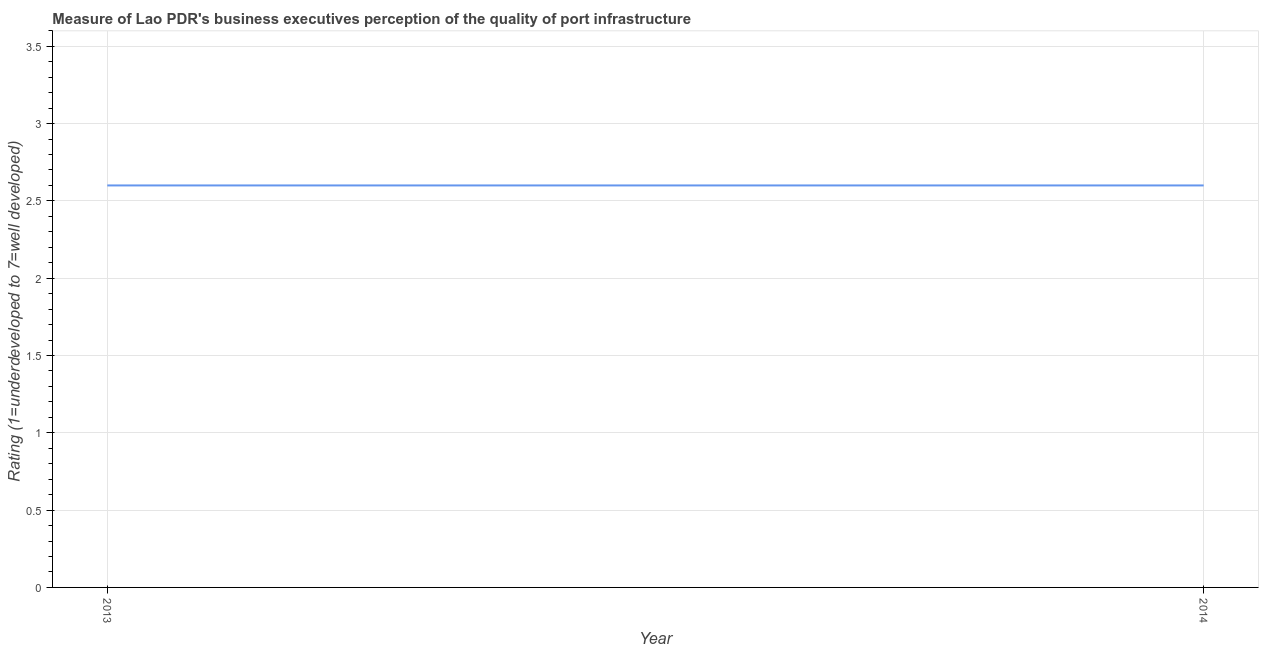What is the rating measuring quality of port infrastructure in 2014?
Offer a very short reply. 2.6. What is the difference between the rating measuring quality of port infrastructure in 2013 and 2014?
Your answer should be very brief. 0. What is the median rating measuring quality of port infrastructure?
Your response must be concise. 2.6. In how many years, is the rating measuring quality of port infrastructure greater than 2.4 ?
Provide a succinct answer. 2. Is the rating measuring quality of port infrastructure in 2013 less than that in 2014?
Provide a short and direct response. No. In how many years, is the rating measuring quality of port infrastructure greater than the average rating measuring quality of port infrastructure taken over all years?
Give a very brief answer. 0. What is the difference between two consecutive major ticks on the Y-axis?
Provide a short and direct response. 0.5. Does the graph contain grids?
Your answer should be compact. Yes. What is the title of the graph?
Keep it short and to the point. Measure of Lao PDR's business executives perception of the quality of port infrastructure. What is the label or title of the Y-axis?
Offer a terse response. Rating (1=underdeveloped to 7=well developed) . What is the difference between the Rating (1=underdeveloped to 7=well developed)  in 2013 and 2014?
Provide a succinct answer. 0. What is the ratio of the Rating (1=underdeveloped to 7=well developed)  in 2013 to that in 2014?
Make the answer very short. 1. 